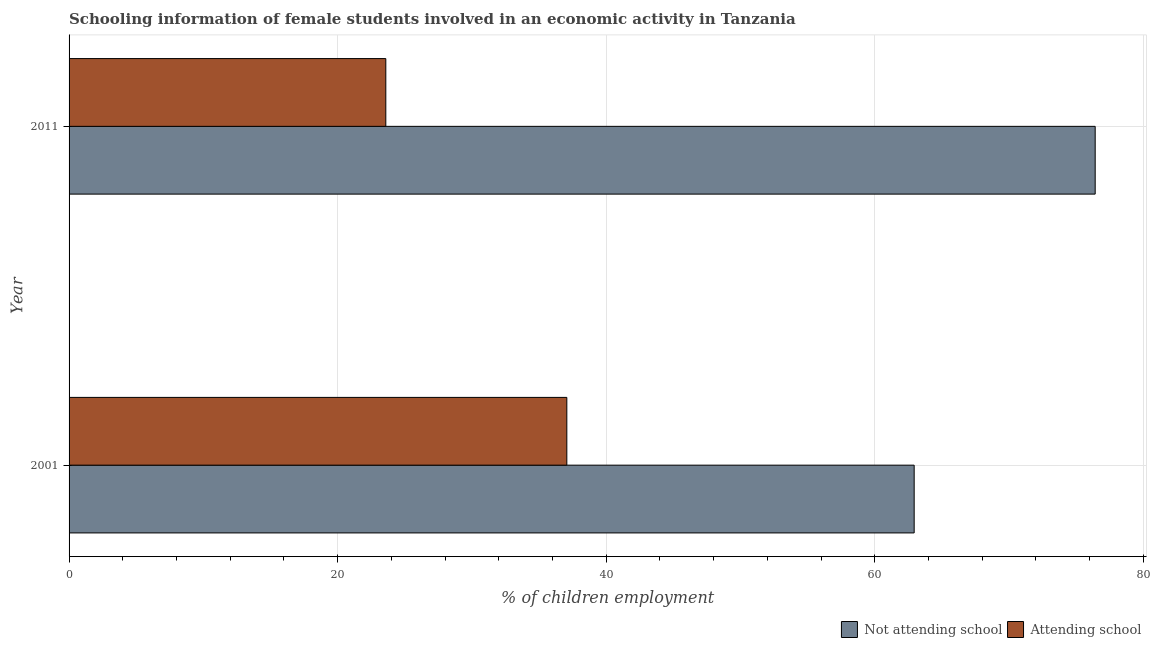How many different coloured bars are there?
Ensure brevity in your answer.  2. How many groups of bars are there?
Offer a very short reply. 2. Are the number of bars per tick equal to the number of legend labels?
Your answer should be compact. Yes. In how many cases, is the number of bars for a given year not equal to the number of legend labels?
Your answer should be very brief. 0. What is the percentage of employed females who are not attending school in 2011?
Provide a short and direct response. 76.41. Across all years, what is the maximum percentage of employed females who are not attending school?
Provide a succinct answer. 76.41. Across all years, what is the minimum percentage of employed females who are not attending school?
Your answer should be compact. 62.93. What is the total percentage of employed females who are attending school in the graph?
Your answer should be compact. 60.65. What is the difference between the percentage of employed females who are not attending school in 2001 and that in 2011?
Offer a very short reply. -13.48. What is the difference between the percentage of employed females who are not attending school in 2011 and the percentage of employed females who are attending school in 2001?
Offer a terse response. 39.35. What is the average percentage of employed females who are not attending school per year?
Your answer should be compact. 69.67. In the year 2011, what is the difference between the percentage of employed females who are not attending school and percentage of employed females who are attending school?
Your answer should be very brief. 52.83. What is the ratio of the percentage of employed females who are not attending school in 2001 to that in 2011?
Keep it short and to the point. 0.82. Is the difference between the percentage of employed females who are not attending school in 2001 and 2011 greater than the difference between the percentage of employed females who are attending school in 2001 and 2011?
Ensure brevity in your answer.  No. What does the 2nd bar from the top in 2001 represents?
Provide a short and direct response. Not attending school. What does the 1st bar from the bottom in 2001 represents?
Keep it short and to the point. Not attending school. Are all the bars in the graph horizontal?
Give a very brief answer. Yes. Are the values on the major ticks of X-axis written in scientific E-notation?
Keep it short and to the point. No. How are the legend labels stacked?
Your answer should be very brief. Horizontal. What is the title of the graph?
Provide a succinct answer. Schooling information of female students involved in an economic activity in Tanzania. Does "Highest 10% of population" appear as one of the legend labels in the graph?
Offer a terse response. No. What is the label or title of the X-axis?
Ensure brevity in your answer.  % of children employment. What is the label or title of the Y-axis?
Make the answer very short. Year. What is the % of children employment of Not attending school in 2001?
Keep it short and to the point. 62.93. What is the % of children employment in Attending school in 2001?
Make the answer very short. 37.07. What is the % of children employment of Not attending school in 2011?
Offer a very short reply. 76.41. What is the % of children employment in Attending school in 2011?
Your answer should be compact. 23.59. Across all years, what is the maximum % of children employment in Not attending school?
Provide a short and direct response. 76.41. Across all years, what is the maximum % of children employment in Attending school?
Make the answer very short. 37.07. Across all years, what is the minimum % of children employment in Not attending school?
Keep it short and to the point. 62.93. Across all years, what is the minimum % of children employment of Attending school?
Your response must be concise. 23.59. What is the total % of children employment of Not attending school in the graph?
Provide a short and direct response. 139.35. What is the total % of children employment of Attending school in the graph?
Your response must be concise. 60.65. What is the difference between the % of children employment of Not attending school in 2001 and that in 2011?
Provide a succinct answer. -13.48. What is the difference between the % of children employment of Attending school in 2001 and that in 2011?
Give a very brief answer. 13.48. What is the difference between the % of children employment of Not attending school in 2001 and the % of children employment of Attending school in 2011?
Provide a succinct answer. 39.35. What is the average % of children employment of Not attending school per year?
Offer a very short reply. 69.67. What is the average % of children employment in Attending school per year?
Make the answer very short. 30.33. In the year 2001, what is the difference between the % of children employment in Not attending school and % of children employment in Attending school?
Your response must be concise. 25.87. In the year 2011, what is the difference between the % of children employment of Not attending school and % of children employment of Attending school?
Ensure brevity in your answer.  52.83. What is the ratio of the % of children employment in Not attending school in 2001 to that in 2011?
Provide a succinct answer. 0.82. What is the ratio of the % of children employment in Attending school in 2001 to that in 2011?
Keep it short and to the point. 1.57. What is the difference between the highest and the second highest % of children employment of Not attending school?
Ensure brevity in your answer.  13.48. What is the difference between the highest and the second highest % of children employment in Attending school?
Provide a short and direct response. 13.48. What is the difference between the highest and the lowest % of children employment of Not attending school?
Provide a short and direct response. 13.48. What is the difference between the highest and the lowest % of children employment of Attending school?
Your answer should be very brief. 13.48. 